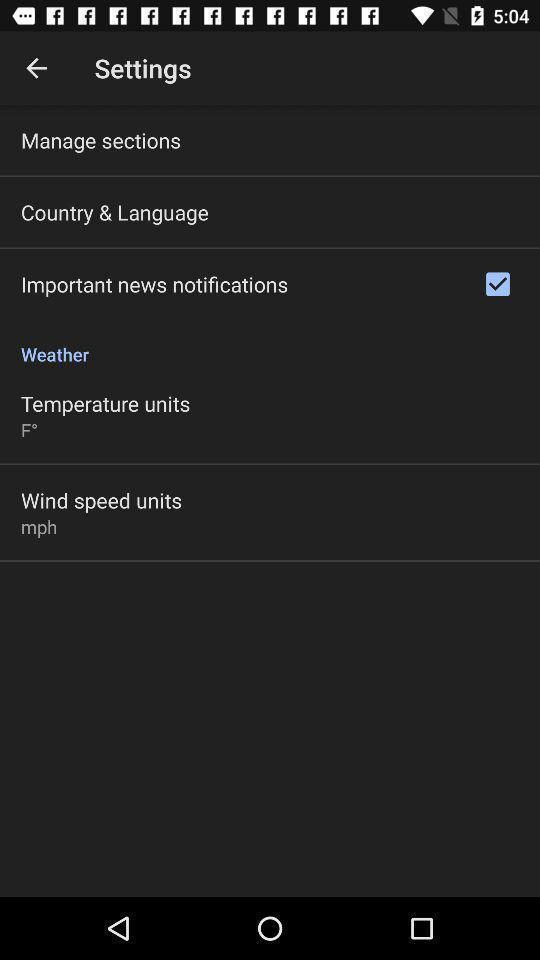What can you discern from this picture? Settings page. 